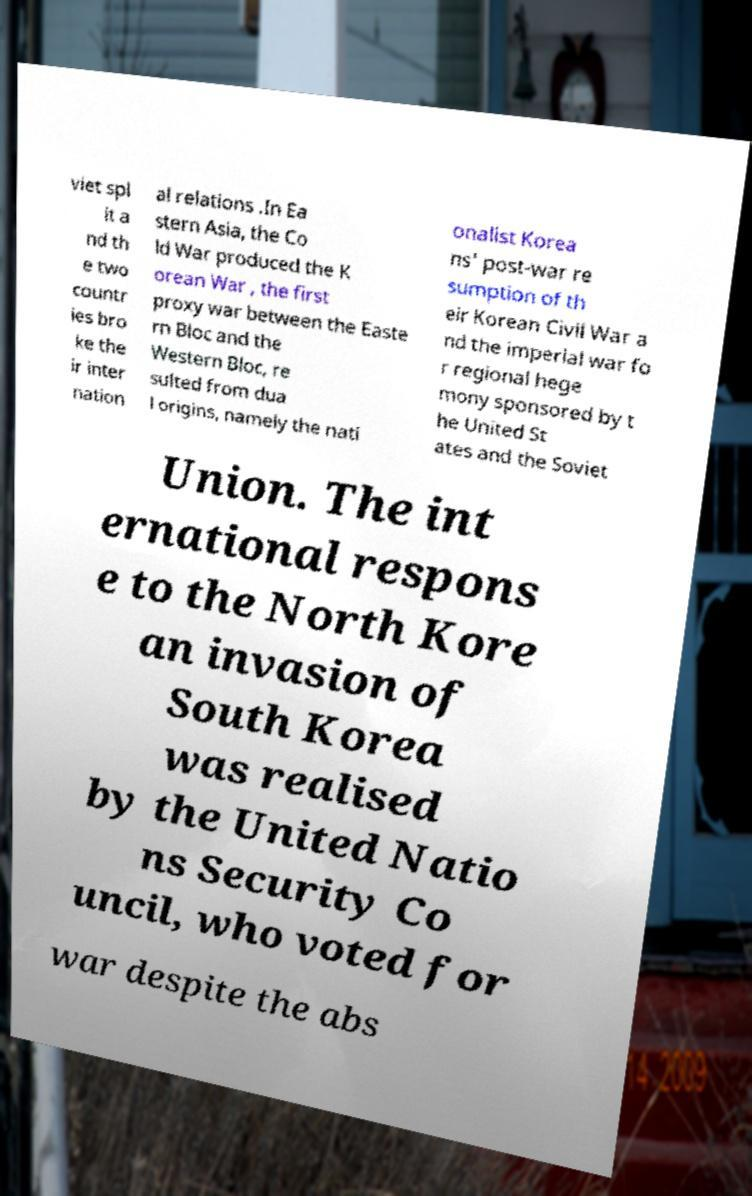Please read and relay the text visible in this image. What does it say? viet spl it a nd th e two countr ies bro ke the ir inter nation al relations .In Ea stern Asia, the Co ld War produced the K orean War , the first proxy war between the Easte rn Bloc and the Western Bloc, re sulted from dua l origins, namely the nati onalist Korea ns' post-war re sumption of th eir Korean Civil War a nd the imperial war fo r regional hege mony sponsored by t he United St ates and the Soviet Union. The int ernational respons e to the North Kore an invasion of South Korea was realised by the United Natio ns Security Co uncil, who voted for war despite the abs 